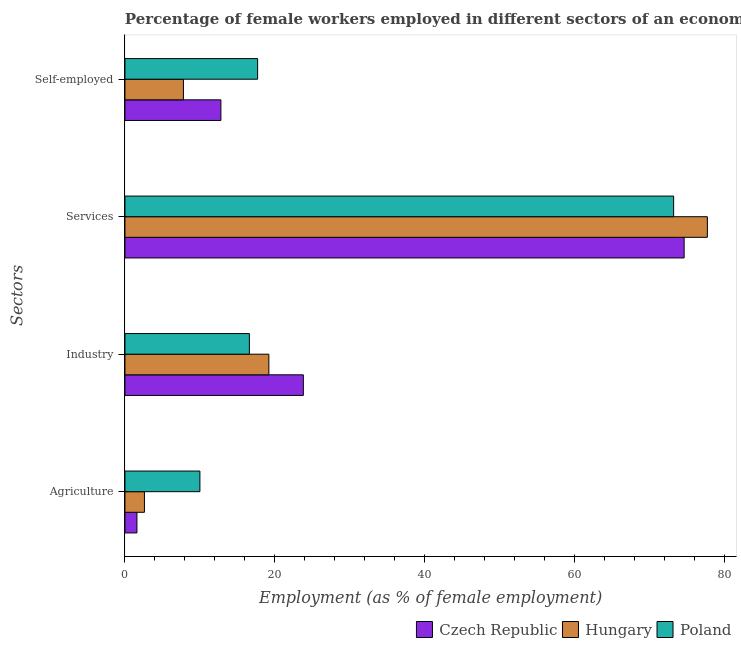What is the label of the 1st group of bars from the top?
Your response must be concise. Self-employed. What is the percentage of female workers in industry in Czech Republic?
Provide a succinct answer. 23.8. Across all countries, what is the maximum percentage of female workers in industry?
Keep it short and to the point. 23.8. Across all countries, what is the minimum percentage of self employed female workers?
Make the answer very short. 7.8. In which country was the percentage of female workers in industry maximum?
Offer a terse response. Czech Republic. In which country was the percentage of self employed female workers minimum?
Provide a short and direct response. Hungary. What is the total percentage of self employed female workers in the graph?
Offer a very short reply. 38.3. What is the difference between the percentage of female workers in industry in Hungary and that in Poland?
Your answer should be very brief. 2.6. What is the difference between the percentage of female workers in services in Poland and the percentage of female workers in agriculture in Hungary?
Offer a very short reply. 70.6. What is the average percentage of female workers in services per country?
Make the answer very short. 75.17. What is the difference between the percentage of self employed female workers and percentage of female workers in agriculture in Poland?
Offer a very short reply. 7.7. What is the ratio of the percentage of self employed female workers in Hungary to that in Poland?
Provide a short and direct response. 0.44. Is the percentage of self employed female workers in Czech Republic less than that in Poland?
Give a very brief answer. Yes. What is the difference between the highest and the second highest percentage of self employed female workers?
Your answer should be compact. 4.9. What is the difference between the highest and the lowest percentage of self employed female workers?
Offer a very short reply. 9.9. In how many countries, is the percentage of female workers in agriculture greater than the average percentage of female workers in agriculture taken over all countries?
Provide a succinct answer. 1. Is the sum of the percentage of self employed female workers in Poland and Hungary greater than the maximum percentage of female workers in industry across all countries?
Provide a succinct answer. Yes. What does the 3rd bar from the top in Agriculture represents?
Provide a succinct answer. Czech Republic. What does the 2nd bar from the bottom in Industry represents?
Give a very brief answer. Hungary. How many bars are there?
Your answer should be compact. 12. How many countries are there in the graph?
Offer a very short reply. 3. What is the difference between two consecutive major ticks on the X-axis?
Keep it short and to the point. 20. Are the values on the major ticks of X-axis written in scientific E-notation?
Your answer should be very brief. No. Where does the legend appear in the graph?
Your answer should be very brief. Bottom right. How many legend labels are there?
Provide a short and direct response. 3. How are the legend labels stacked?
Ensure brevity in your answer.  Horizontal. What is the title of the graph?
Your answer should be compact. Percentage of female workers employed in different sectors of an economy in 2014. What is the label or title of the X-axis?
Offer a very short reply. Employment (as % of female employment). What is the label or title of the Y-axis?
Your answer should be very brief. Sectors. What is the Employment (as % of female employment) in Czech Republic in Agriculture?
Your response must be concise. 1.6. What is the Employment (as % of female employment) of Hungary in Agriculture?
Your answer should be very brief. 2.6. What is the Employment (as % of female employment) in Poland in Agriculture?
Provide a short and direct response. 10. What is the Employment (as % of female employment) in Czech Republic in Industry?
Offer a very short reply. 23.8. What is the Employment (as % of female employment) in Hungary in Industry?
Offer a very short reply. 19.2. What is the Employment (as % of female employment) of Poland in Industry?
Your answer should be very brief. 16.6. What is the Employment (as % of female employment) of Czech Republic in Services?
Give a very brief answer. 74.6. What is the Employment (as % of female employment) in Hungary in Services?
Offer a very short reply. 77.7. What is the Employment (as % of female employment) in Poland in Services?
Give a very brief answer. 73.2. What is the Employment (as % of female employment) of Czech Republic in Self-employed?
Your response must be concise. 12.8. What is the Employment (as % of female employment) of Hungary in Self-employed?
Provide a short and direct response. 7.8. What is the Employment (as % of female employment) in Poland in Self-employed?
Your response must be concise. 17.7. Across all Sectors, what is the maximum Employment (as % of female employment) in Czech Republic?
Make the answer very short. 74.6. Across all Sectors, what is the maximum Employment (as % of female employment) of Hungary?
Ensure brevity in your answer.  77.7. Across all Sectors, what is the maximum Employment (as % of female employment) of Poland?
Provide a succinct answer. 73.2. Across all Sectors, what is the minimum Employment (as % of female employment) in Czech Republic?
Your response must be concise. 1.6. Across all Sectors, what is the minimum Employment (as % of female employment) of Hungary?
Your answer should be compact. 2.6. What is the total Employment (as % of female employment) in Czech Republic in the graph?
Offer a very short reply. 112.8. What is the total Employment (as % of female employment) of Hungary in the graph?
Provide a short and direct response. 107.3. What is the total Employment (as % of female employment) of Poland in the graph?
Keep it short and to the point. 117.5. What is the difference between the Employment (as % of female employment) of Czech Republic in Agriculture and that in Industry?
Your response must be concise. -22.2. What is the difference between the Employment (as % of female employment) of Hungary in Agriculture and that in Industry?
Provide a short and direct response. -16.6. What is the difference between the Employment (as % of female employment) in Czech Republic in Agriculture and that in Services?
Make the answer very short. -73. What is the difference between the Employment (as % of female employment) of Hungary in Agriculture and that in Services?
Offer a terse response. -75.1. What is the difference between the Employment (as % of female employment) in Poland in Agriculture and that in Services?
Keep it short and to the point. -63.2. What is the difference between the Employment (as % of female employment) in Czech Republic in Agriculture and that in Self-employed?
Keep it short and to the point. -11.2. What is the difference between the Employment (as % of female employment) of Czech Republic in Industry and that in Services?
Give a very brief answer. -50.8. What is the difference between the Employment (as % of female employment) in Hungary in Industry and that in Services?
Keep it short and to the point. -58.5. What is the difference between the Employment (as % of female employment) of Poland in Industry and that in Services?
Keep it short and to the point. -56.6. What is the difference between the Employment (as % of female employment) in Czech Republic in Industry and that in Self-employed?
Your answer should be very brief. 11. What is the difference between the Employment (as % of female employment) of Poland in Industry and that in Self-employed?
Keep it short and to the point. -1.1. What is the difference between the Employment (as % of female employment) in Czech Republic in Services and that in Self-employed?
Provide a short and direct response. 61.8. What is the difference between the Employment (as % of female employment) in Hungary in Services and that in Self-employed?
Provide a short and direct response. 69.9. What is the difference between the Employment (as % of female employment) in Poland in Services and that in Self-employed?
Your answer should be very brief. 55.5. What is the difference between the Employment (as % of female employment) of Czech Republic in Agriculture and the Employment (as % of female employment) of Hungary in Industry?
Ensure brevity in your answer.  -17.6. What is the difference between the Employment (as % of female employment) in Czech Republic in Agriculture and the Employment (as % of female employment) in Poland in Industry?
Provide a succinct answer. -15. What is the difference between the Employment (as % of female employment) of Czech Republic in Agriculture and the Employment (as % of female employment) of Hungary in Services?
Keep it short and to the point. -76.1. What is the difference between the Employment (as % of female employment) in Czech Republic in Agriculture and the Employment (as % of female employment) in Poland in Services?
Make the answer very short. -71.6. What is the difference between the Employment (as % of female employment) in Hungary in Agriculture and the Employment (as % of female employment) in Poland in Services?
Your response must be concise. -70.6. What is the difference between the Employment (as % of female employment) in Czech Republic in Agriculture and the Employment (as % of female employment) in Hungary in Self-employed?
Make the answer very short. -6.2. What is the difference between the Employment (as % of female employment) of Czech Republic in Agriculture and the Employment (as % of female employment) of Poland in Self-employed?
Your response must be concise. -16.1. What is the difference between the Employment (as % of female employment) in Hungary in Agriculture and the Employment (as % of female employment) in Poland in Self-employed?
Make the answer very short. -15.1. What is the difference between the Employment (as % of female employment) in Czech Republic in Industry and the Employment (as % of female employment) in Hungary in Services?
Offer a terse response. -53.9. What is the difference between the Employment (as % of female employment) in Czech Republic in Industry and the Employment (as % of female employment) in Poland in Services?
Make the answer very short. -49.4. What is the difference between the Employment (as % of female employment) of Hungary in Industry and the Employment (as % of female employment) of Poland in Services?
Your response must be concise. -54. What is the difference between the Employment (as % of female employment) of Czech Republic in Industry and the Employment (as % of female employment) of Hungary in Self-employed?
Make the answer very short. 16. What is the difference between the Employment (as % of female employment) of Hungary in Industry and the Employment (as % of female employment) of Poland in Self-employed?
Offer a terse response. 1.5. What is the difference between the Employment (as % of female employment) of Czech Republic in Services and the Employment (as % of female employment) of Hungary in Self-employed?
Your response must be concise. 66.8. What is the difference between the Employment (as % of female employment) in Czech Republic in Services and the Employment (as % of female employment) in Poland in Self-employed?
Give a very brief answer. 56.9. What is the average Employment (as % of female employment) in Czech Republic per Sectors?
Your answer should be compact. 28.2. What is the average Employment (as % of female employment) of Hungary per Sectors?
Offer a terse response. 26.82. What is the average Employment (as % of female employment) in Poland per Sectors?
Keep it short and to the point. 29.38. What is the difference between the Employment (as % of female employment) of Czech Republic and Employment (as % of female employment) of Poland in Agriculture?
Offer a very short reply. -8.4. What is the difference between the Employment (as % of female employment) in Czech Republic and Employment (as % of female employment) in Hungary in Industry?
Give a very brief answer. 4.6. What is the difference between the Employment (as % of female employment) in Hungary and Employment (as % of female employment) in Poland in Industry?
Offer a very short reply. 2.6. What is the difference between the Employment (as % of female employment) of Czech Republic and Employment (as % of female employment) of Poland in Services?
Provide a short and direct response. 1.4. What is the difference between the Employment (as % of female employment) of Czech Republic and Employment (as % of female employment) of Hungary in Self-employed?
Make the answer very short. 5. What is the ratio of the Employment (as % of female employment) in Czech Republic in Agriculture to that in Industry?
Give a very brief answer. 0.07. What is the ratio of the Employment (as % of female employment) of Hungary in Agriculture to that in Industry?
Your answer should be very brief. 0.14. What is the ratio of the Employment (as % of female employment) of Poland in Agriculture to that in Industry?
Ensure brevity in your answer.  0.6. What is the ratio of the Employment (as % of female employment) in Czech Republic in Agriculture to that in Services?
Provide a succinct answer. 0.02. What is the ratio of the Employment (as % of female employment) of Hungary in Agriculture to that in Services?
Provide a succinct answer. 0.03. What is the ratio of the Employment (as % of female employment) in Poland in Agriculture to that in Services?
Your answer should be compact. 0.14. What is the ratio of the Employment (as % of female employment) in Czech Republic in Agriculture to that in Self-employed?
Ensure brevity in your answer.  0.12. What is the ratio of the Employment (as % of female employment) in Hungary in Agriculture to that in Self-employed?
Give a very brief answer. 0.33. What is the ratio of the Employment (as % of female employment) of Poland in Agriculture to that in Self-employed?
Your answer should be very brief. 0.56. What is the ratio of the Employment (as % of female employment) in Czech Republic in Industry to that in Services?
Give a very brief answer. 0.32. What is the ratio of the Employment (as % of female employment) of Hungary in Industry to that in Services?
Ensure brevity in your answer.  0.25. What is the ratio of the Employment (as % of female employment) in Poland in Industry to that in Services?
Your answer should be very brief. 0.23. What is the ratio of the Employment (as % of female employment) of Czech Republic in Industry to that in Self-employed?
Provide a succinct answer. 1.86. What is the ratio of the Employment (as % of female employment) of Hungary in Industry to that in Self-employed?
Your response must be concise. 2.46. What is the ratio of the Employment (as % of female employment) of Poland in Industry to that in Self-employed?
Keep it short and to the point. 0.94. What is the ratio of the Employment (as % of female employment) in Czech Republic in Services to that in Self-employed?
Give a very brief answer. 5.83. What is the ratio of the Employment (as % of female employment) of Hungary in Services to that in Self-employed?
Make the answer very short. 9.96. What is the ratio of the Employment (as % of female employment) in Poland in Services to that in Self-employed?
Keep it short and to the point. 4.14. What is the difference between the highest and the second highest Employment (as % of female employment) of Czech Republic?
Ensure brevity in your answer.  50.8. What is the difference between the highest and the second highest Employment (as % of female employment) in Hungary?
Your answer should be compact. 58.5. What is the difference between the highest and the second highest Employment (as % of female employment) of Poland?
Offer a terse response. 55.5. What is the difference between the highest and the lowest Employment (as % of female employment) of Czech Republic?
Your response must be concise. 73. What is the difference between the highest and the lowest Employment (as % of female employment) of Hungary?
Your answer should be very brief. 75.1. What is the difference between the highest and the lowest Employment (as % of female employment) of Poland?
Your answer should be very brief. 63.2. 